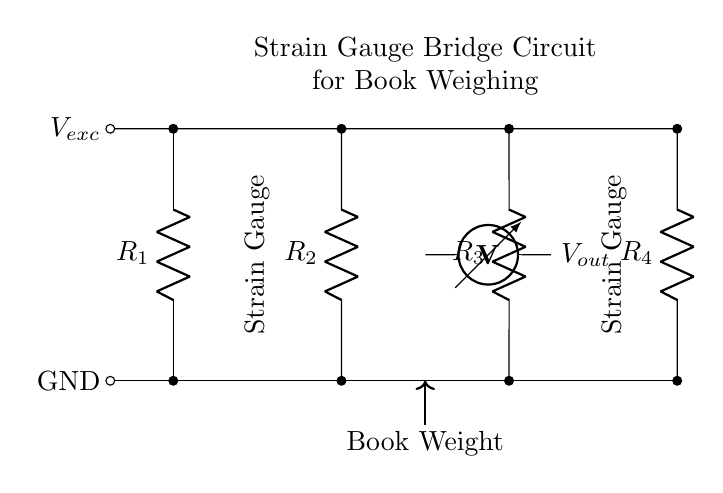What components are included in this circuit? The circuit includes four resistors labeled R1, R2, R3, and R4, and two strain gauges.
Answer: R1, R2, R3, R4, strain gauges What is the output voltage of the circuit? The output voltage can be measured at the points connected to the voltmeter symbol in the diagram, indicated as Vout.
Answer: Vout What is the function of the strain gauges in this circuit? Strain gauges change their resistance based on the deformation they experience when weight is applied, which allows for the measurement of weight in the bridge circuit.
Answer: Measure weight How many resistors are in the bridge circuit? The diagram illustrates that there are four resistors connected in a bridge formation, specifically R1, R2, R3, and R4.
Answer: Four What happens to the output voltage if one strain gauge increases in resistance? If one strain gauge increases in resistance, it will create an imbalance in the bridge circuit, causing Vout to change depending on the specifics of the circuit configuration.
Answer: Changes What configuration is this circuit using? This circuit uses a Wheatstone bridge configuration, which is typically applied for measuring unknown resistances via the changes caused by the strain gauges.
Answer: Wheatstone bridge What is the purpose of the voltage excitation in this circuit? The voltage excitation (Vexc) provides the electrical power needed for the circuit to operate and allows the strain gauges to function properly by creating the potential difference for measurement.
Answer: Power supply 